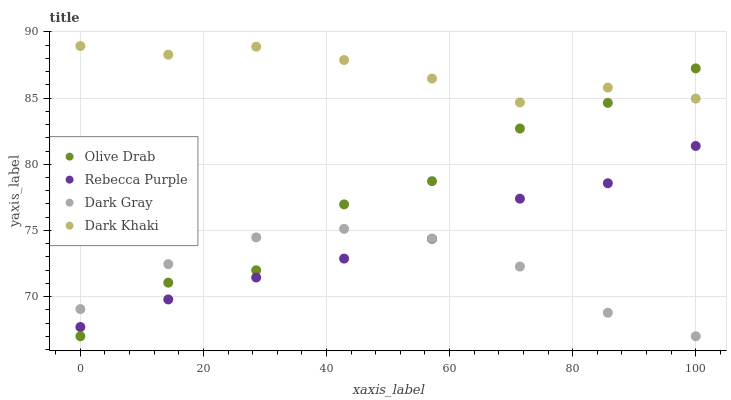Does Dark Gray have the minimum area under the curve?
Answer yes or no. Yes. Does Dark Khaki have the maximum area under the curve?
Answer yes or no. Yes. Does Rebecca Purple have the minimum area under the curve?
Answer yes or no. No. Does Rebecca Purple have the maximum area under the curve?
Answer yes or no. No. Is Rebecca Purple the smoothest?
Answer yes or no. Yes. Is Olive Drab the roughest?
Answer yes or no. Yes. Is Dark Khaki the smoothest?
Answer yes or no. No. Is Dark Khaki the roughest?
Answer yes or no. No. Does Dark Gray have the lowest value?
Answer yes or no. Yes. Does Rebecca Purple have the lowest value?
Answer yes or no. No. Does Dark Khaki have the highest value?
Answer yes or no. Yes. Does Rebecca Purple have the highest value?
Answer yes or no. No. Is Rebecca Purple less than Dark Khaki?
Answer yes or no. Yes. Is Dark Khaki greater than Dark Gray?
Answer yes or no. Yes. Does Rebecca Purple intersect Dark Gray?
Answer yes or no. Yes. Is Rebecca Purple less than Dark Gray?
Answer yes or no. No. Is Rebecca Purple greater than Dark Gray?
Answer yes or no. No. Does Rebecca Purple intersect Dark Khaki?
Answer yes or no. No. 